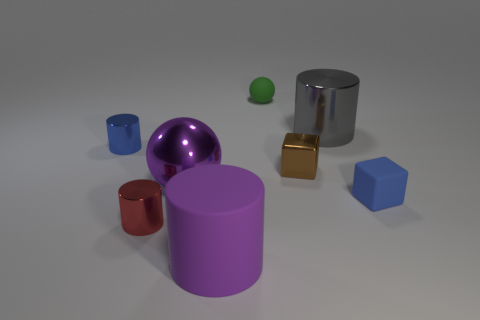There is a ball that is on the left side of the tiny rubber object behind the tiny matte object in front of the blue shiny cylinder; what is it made of?
Keep it short and to the point. Metal. There is a sphere behind the big purple shiny thing; what number of brown shiny things are in front of it?
Offer a very short reply. 1. There is a sphere that is behind the blue cylinder; is its size the same as the big purple cylinder?
Your answer should be compact. No. How many other rubber objects have the same shape as the small green matte object?
Keep it short and to the point. 0. There is a large purple metallic thing; what shape is it?
Give a very brief answer. Sphere. Is the number of big purple metal things that are right of the green object the same as the number of tiny metallic cubes?
Your answer should be very brief. No. Does the blue thing right of the big purple cylinder have the same material as the tiny blue cylinder?
Keep it short and to the point. No. Are there fewer large gray things that are in front of the blue block than shiny balls?
Provide a short and direct response. Yes. How many shiny objects are either large gray objects or cylinders?
Offer a very short reply. 3. Is the big rubber cylinder the same color as the shiny sphere?
Keep it short and to the point. Yes. 